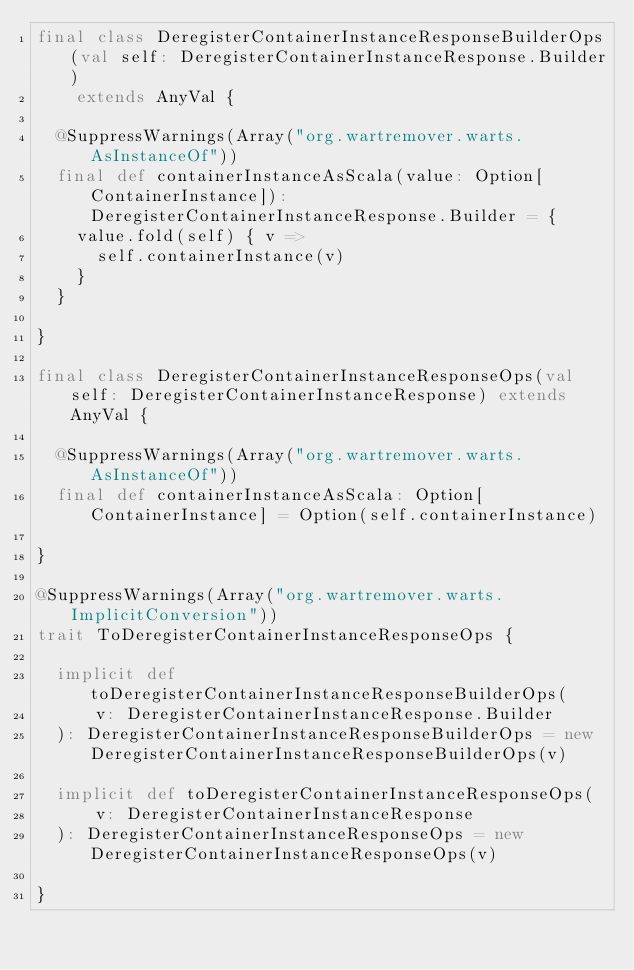<code> <loc_0><loc_0><loc_500><loc_500><_Scala_>final class DeregisterContainerInstanceResponseBuilderOps(val self: DeregisterContainerInstanceResponse.Builder)
    extends AnyVal {

  @SuppressWarnings(Array("org.wartremover.warts.AsInstanceOf"))
  final def containerInstanceAsScala(value: Option[ContainerInstance]): DeregisterContainerInstanceResponse.Builder = {
    value.fold(self) { v =>
      self.containerInstance(v)
    }
  }

}

final class DeregisterContainerInstanceResponseOps(val self: DeregisterContainerInstanceResponse) extends AnyVal {

  @SuppressWarnings(Array("org.wartremover.warts.AsInstanceOf"))
  final def containerInstanceAsScala: Option[ContainerInstance] = Option(self.containerInstance)

}

@SuppressWarnings(Array("org.wartremover.warts.ImplicitConversion"))
trait ToDeregisterContainerInstanceResponseOps {

  implicit def toDeregisterContainerInstanceResponseBuilderOps(
      v: DeregisterContainerInstanceResponse.Builder
  ): DeregisterContainerInstanceResponseBuilderOps = new DeregisterContainerInstanceResponseBuilderOps(v)

  implicit def toDeregisterContainerInstanceResponseOps(
      v: DeregisterContainerInstanceResponse
  ): DeregisterContainerInstanceResponseOps = new DeregisterContainerInstanceResponseOps(v)

}
</code> 